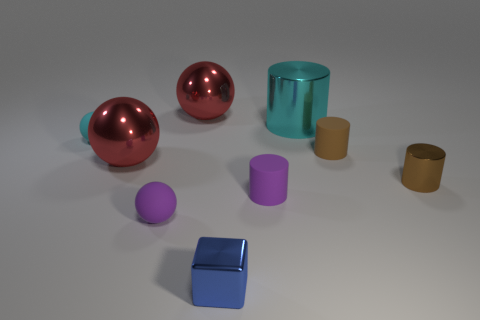Subtract all balls. How many objects are left? 5 Subtract 0 brown balls. How many objects are left? 9 Subtract all large cyan cylinders. Subtract all large red metallic objects. How many objects are left? 6 Add 7 big red spheres. How many big red spheres are left? 9 Add 9 yellow metal spheres. How many yellow metal spheres exist? 9 